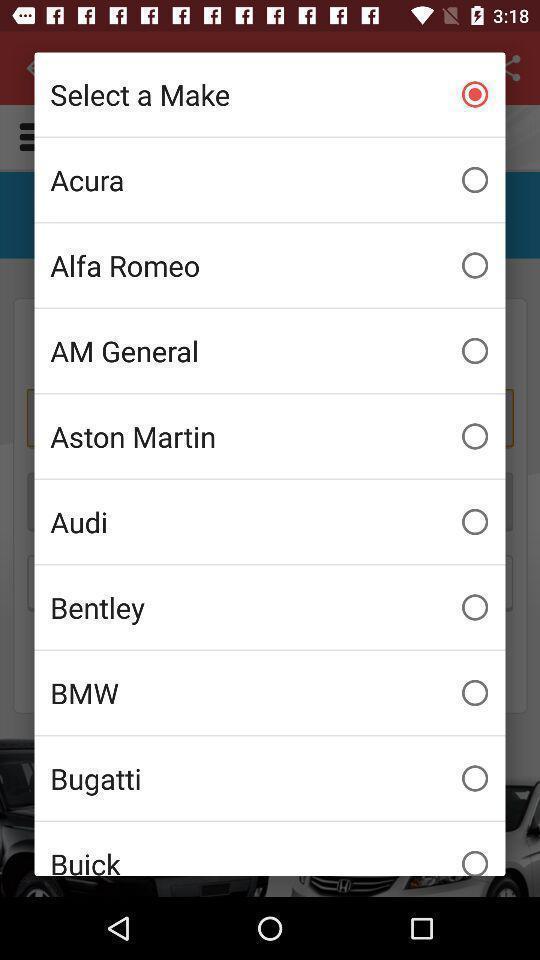Please provide a description for this image. Pop-up showing list of various brands. 